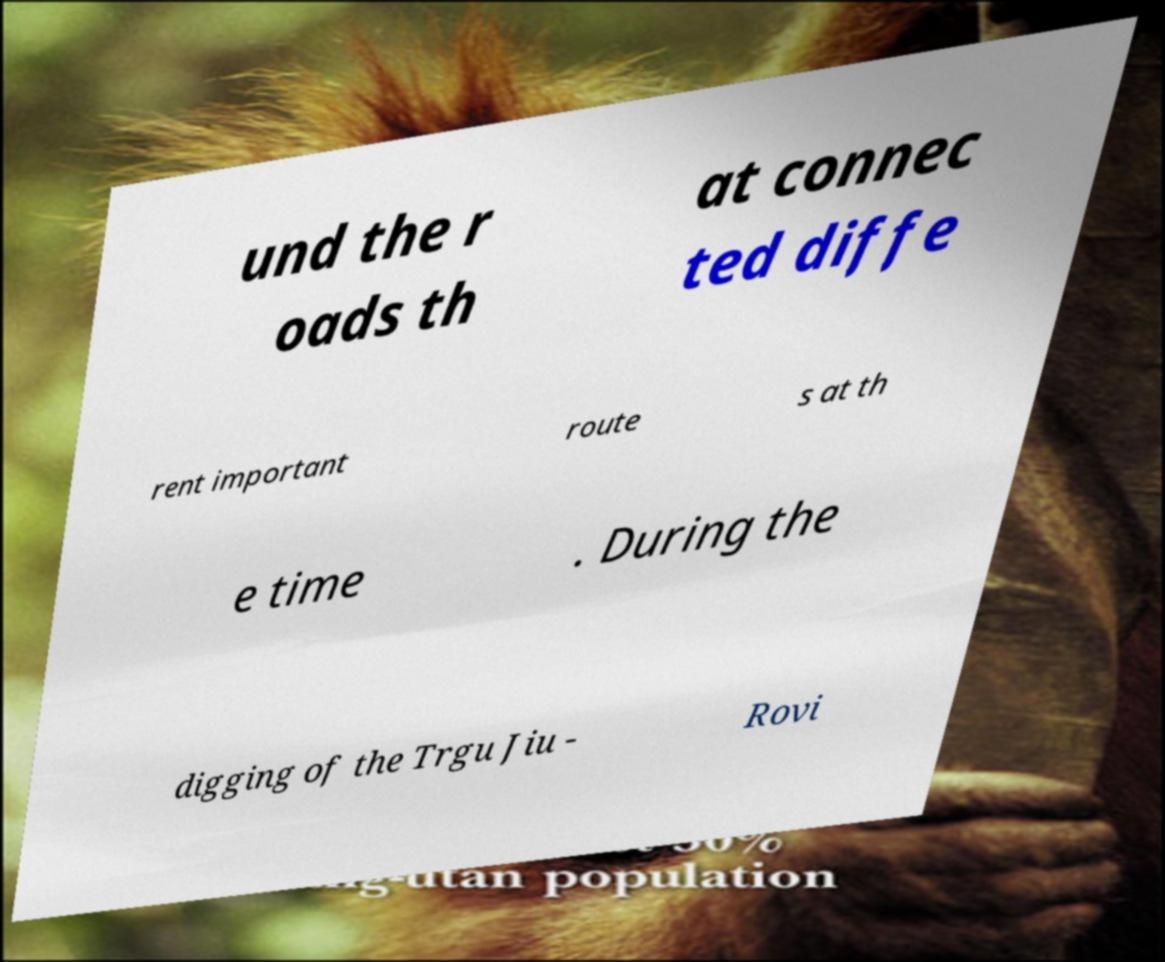For documentation purposes, I need the text within this image transcribed. Could you provide that? und the r oads th at connec ted diffe rent important route s at th e time . During the digging of the Trgu Jiu - Rovi 